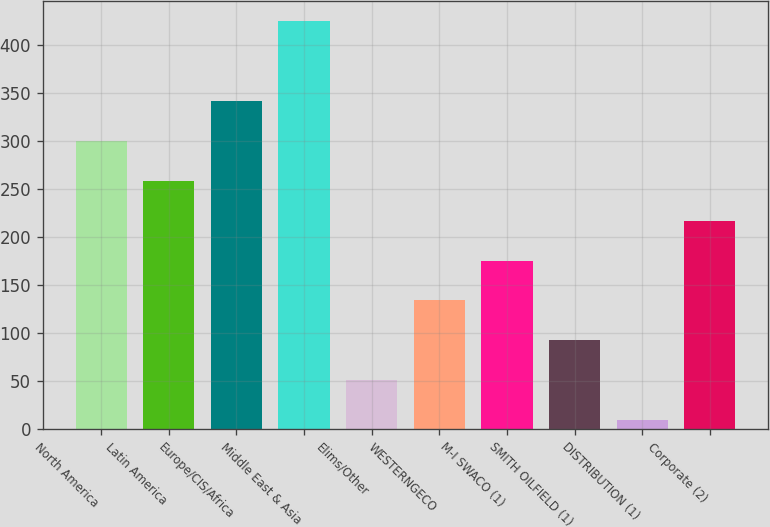Convert chart to OTSL. <chart><loc_0><loc_0><loc_500><loc_500><bar_chart><fcel>North America<fcel>Latin America<fcel>Europe/CIS/Africa<fcel>Middle East & Asia<fcel>Elims/Other<fcel>WESTERNGECO<fcel>M-I SWACO (1)<fcel>SMITH OILFIELD (1)<fcel>DISTRIBUTION (1)<fcel>Corporate (2)<nl><fcel>300.2<fcel>258.6<fcel>341.8<fcel>425<fcel>50.6<fcel>133.8<fcel>175.4<fcel>92.2<fcel>9<fcel>217<nl></chart> 